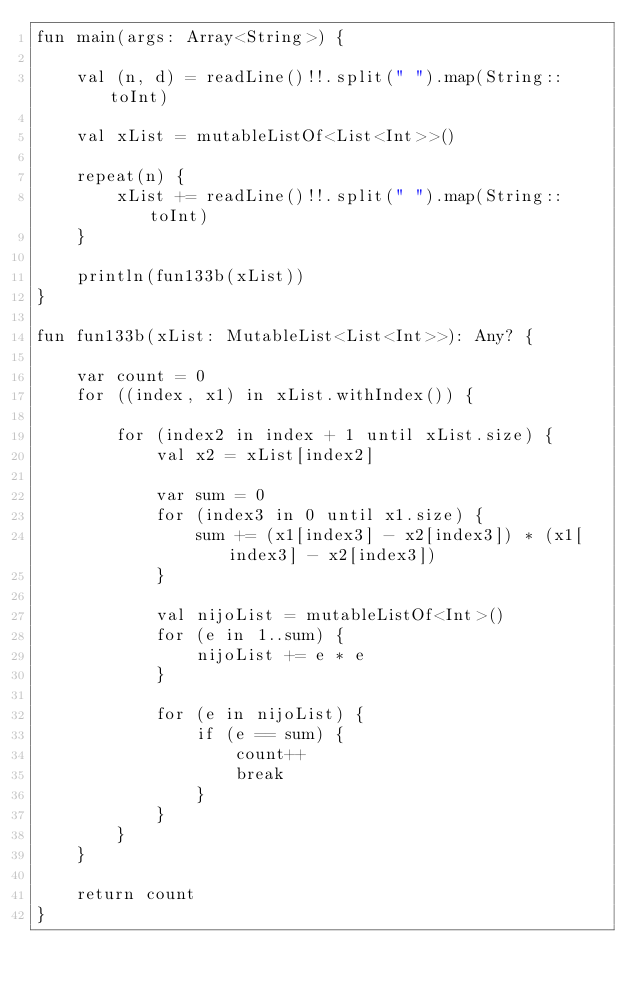Convert code to text. <code><loc_0><loc_0><loc_500><loc_500><_Kotlin_>fun main(args: Array<String>) {

    val (n, d) = readLine()!!.split(" ").map(String::toInt)

    val xList = mutableListOf<List<Int>>()

    repeat(n) {
        xList += readLine()!!.split(" ").map(String::toInt)
    }

    println(fun133b(xList))
}

fun fun133b(xList: MutableList<List<Int>>): Any? {

    var count = 0
    for ((index, x1) in xList.withIndex()) {

        for (index2 in index + 1 until xList.size) {
            val x2 = xList[index2]

            var sum = 0
            for (index3 in 0 until x1.size) {
                sum += (x1[index3] - x2[index3]) * (x1[index3] - x2[index3])
            }

            val nijoList = mutableListOf<Int>()
            for (e in 1..sum) {
                nijoList += e * e
            }

            for (e in nijoList) {
                if (e == sum) {
                    count++
                    break
                }
            }
        }
    }

    return count
}
</code> 